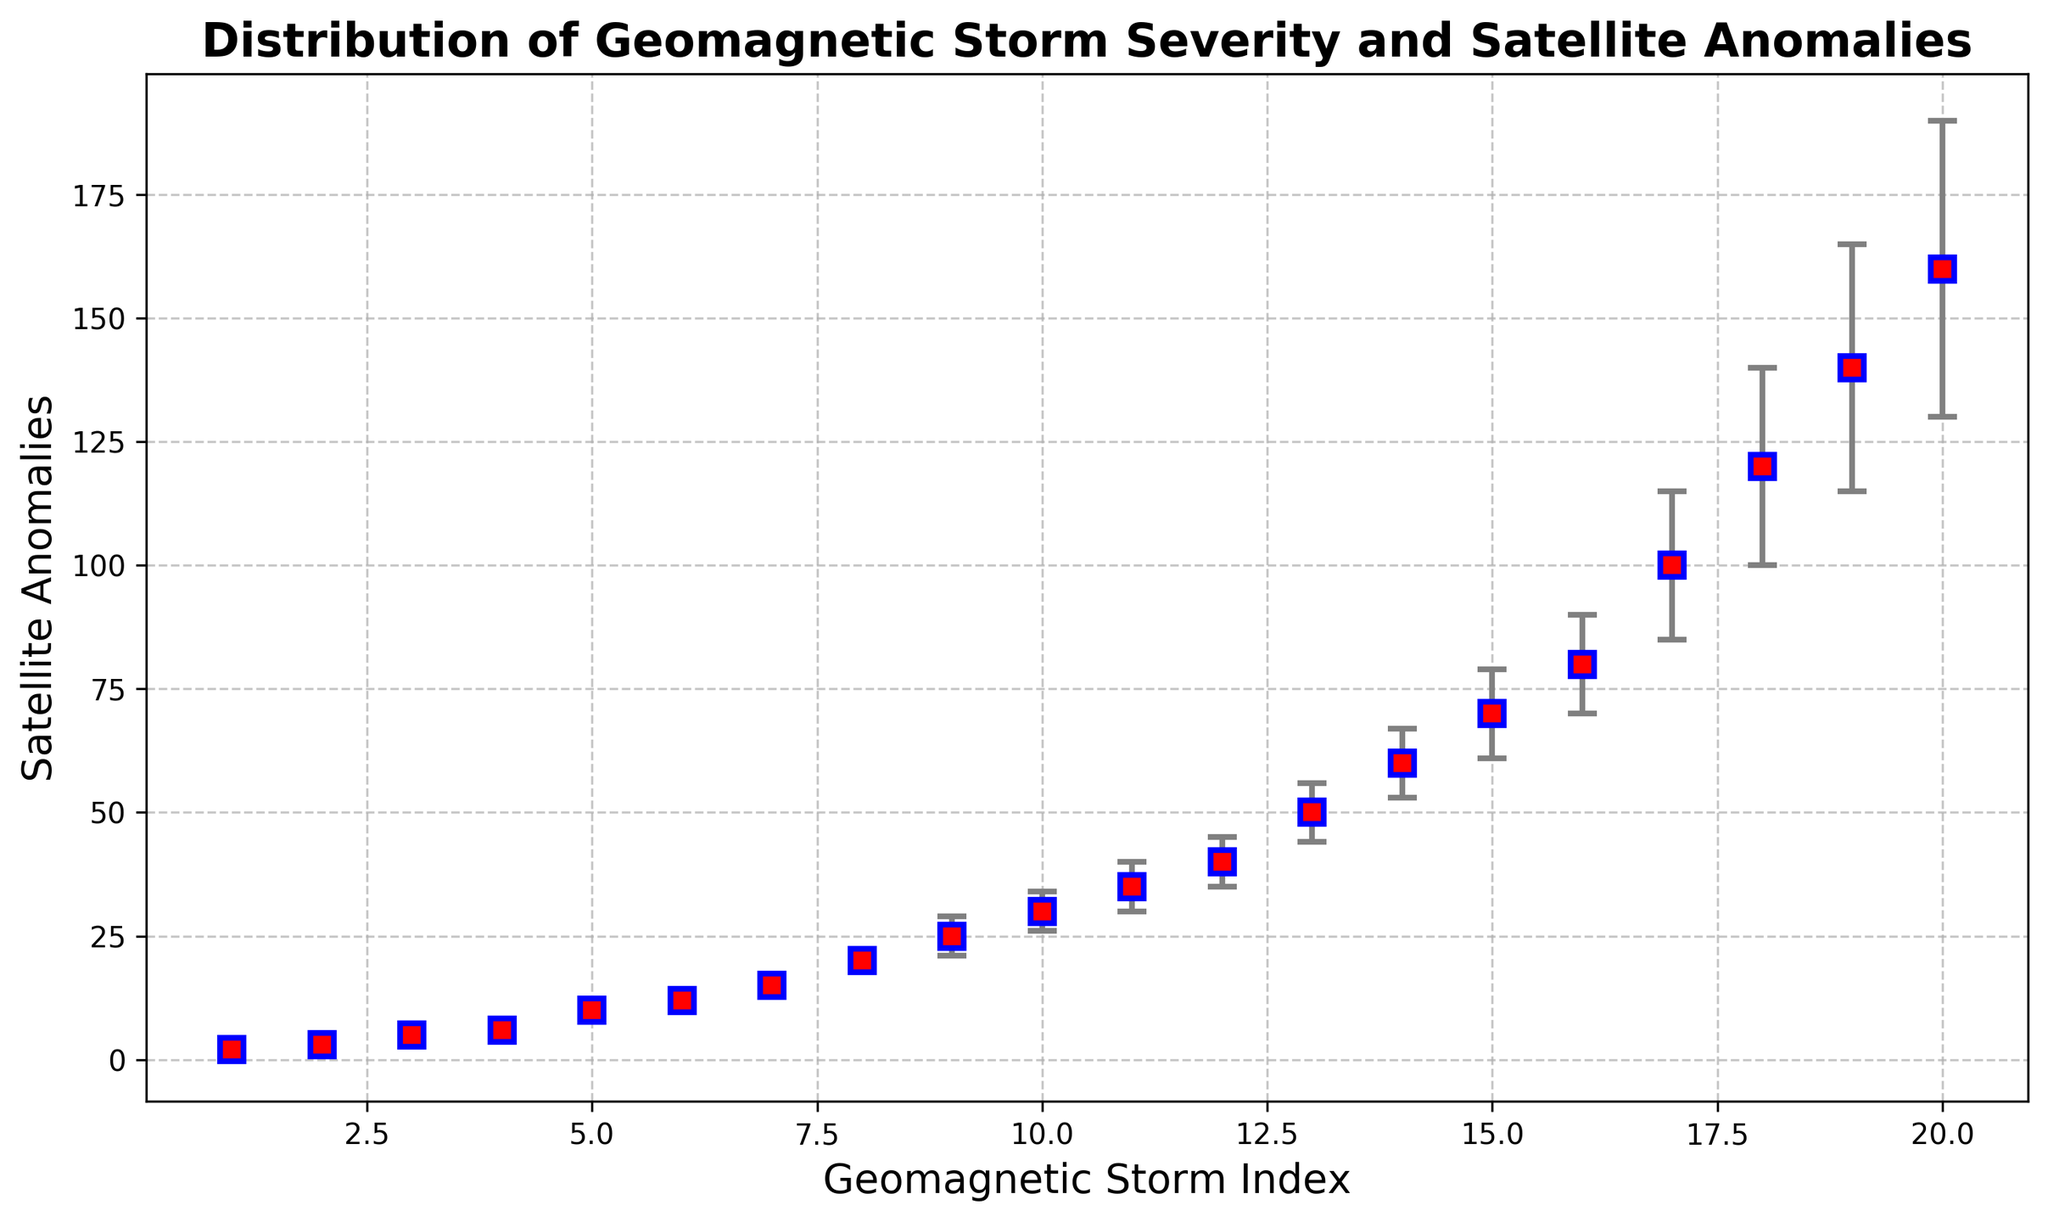Which severity level has the highest number of satellite anomalies? Locate the highest data point on the y-axis, which corresponds to the "Extreme" severity level.
Answer: Extreme Which severity level has the smallest confidence interval for satellite anomalies? Identify the shortest vertical range (error bars) on the figure. The shortest range appears in the "Minor" severity level.
Answer: Minor What is the average number of satellite anomalies during strong geomagnetic storms? For strong storms (index 9 to 12), sum the values (25 + 30 + 35 + 40 = 130) and divide by the number of storms (130 / 4 = 32.5).
Answer: 32.5 By how much do satellite anomalies increase from minor to moderate geomagnetic storms? Compare the average number of anomalies in the minor range (2+3+5+6)/4 = 4 to the moderate range (10+12+15+20)/4 = 14.25. The increase is 14.25 - 4.
Answer: 10.25 Which geomagnetic storm index corresponds to the widest confidence interval, and what is its range? Identify the vertical range with the greatest distance between the lower and upper bounds. The widest interval appears for index 20 (Extreme), which ranges from 130 to 190.
Answer: Index 20, 60 Among the data points where the geomagnetic storm index is an even number, which has the highest satellite anomalies? Inspect data points at even indices (2, 4, 6, 8, 10, 12, 14, 16, 18, 20). The highest value is at index 20 with 160 anomalies.
Answer: Index 20, 160 Are there any severity levels where all data points fall within a particular range of satellite anomalies? If so, what is the range? Identify ranges where each severity level's data points fit. For Minor, all anomalies are between 2 and 6.
Answer: Minor, 2-6 What is the overall trend in satellite anomalies as geomagnetic storm severity increases? Recognize the upward pattern as storm index increases, indicating more anomalies with greater severity.
Answer: Increasing 